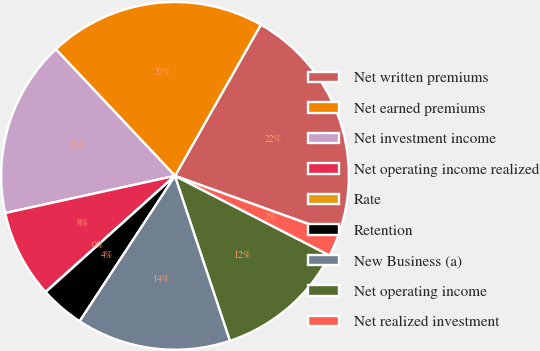<chart> <loc_0><loc_0><loc_500><loc_500><pie_chart><fcel>Net written premiums<fcel>Net earned premiums<fcel>Net investment income<fcel>Net operating income realized<fcel>Rate<fcel>Retention<fcel>New Business (a)<fcel>Net operating income<fcel>Net realized investment<nl><fcel>22.29%<fcel>20.24%<fcel>16.41%<fcel>8.21%<fcel>0.01%<fcel>4.11%<fcel>14.36%<fcel>12.31%<fcel>2.06%<nl></chart> 